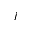Convert formula to latex. <formula><loc_0><loc_0><loc_500><loc_500>j</formula> 